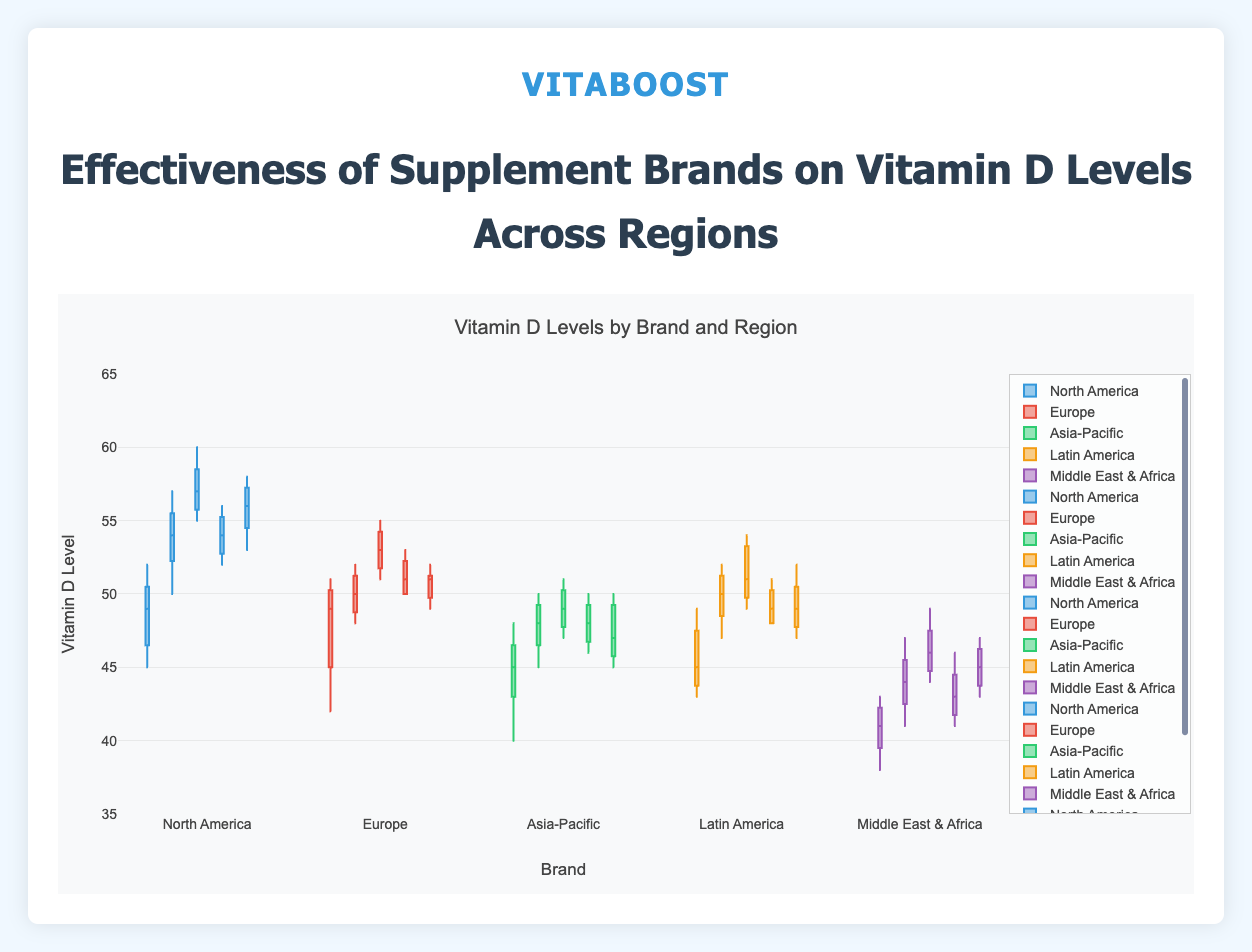What's the title of the figure? The title of the figure is displayed at the top in large font.
Answer: Effectiveness of Supplement Brands on Vitamin D Levels Across Regions What is the highest value recorded for Brand C in North America? The highest value is at the top of the whisker or the highest data point for the North America box plot of Brand C.
Answer: 60 What's the average Vitamin D level for Brand A in Europe? Sum the data points for Brand A in Europe (42, 49, 51, 46, 50) and divide by the number of data points. (42 + 49 + 51 + 46 + 50) / 5 = 238 / 5 = 47.6
Answer: 47.6 Which region shows the lowest median level of Vitamin D for Brand A? The median is the line in the middle of the box. For Brand A, compare the median lines across regions. The lowest one is in the Middle East & Africa.
Answer: Middle East & Africa Is the Vitamin D level spread for Brand B in Europe smaller or larger than in North America? Compare the lengths of the boxes and the whiskers for Brand B in Europe and North America. The spread in North America is larger.
Answer: Larger What can be said about the outliers in the box plots for Brand E in Latin America? Outliers are shown as individual points outside the whiskers. For Brand E in Latin America, there are no outliers.
Answer: No outliers Which brand shows the highest median Vitamin D level in the Middle East & Africa? Compare the median lines for all brands in the Middle East & Africa. Brand C has the highest median.
Answer: Brand C Among all regions, which one has the widest interquartile range (IQR) for Brand D? The IQR is the length of the box. For Brand D, compare the box lengths across regions. No noticeable region has a distinctly wider IQR.
Answer: None significantly wider How do the median Vitamin D levels of Brand E in Europe and Asia-Pacific compare? Compare the median lines within the boxes for Brand E in Europe and Asia-Pacific. The median in Europe is higher.
Answer: Europe is higher 